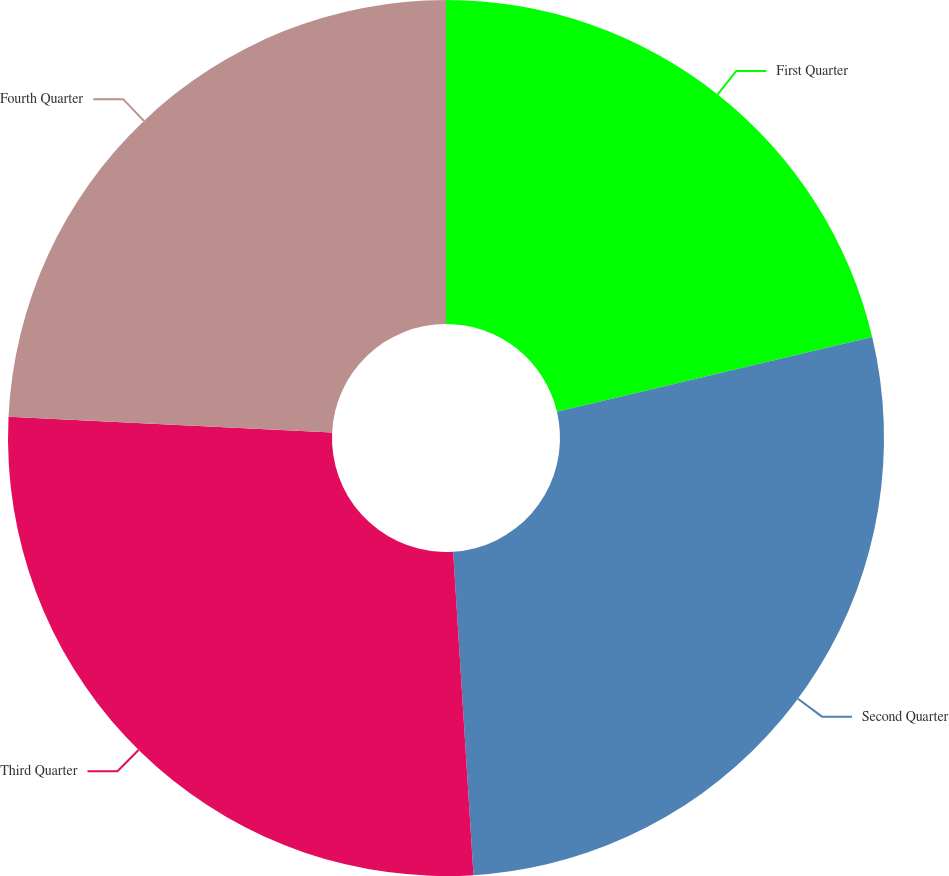Convert chart to OTSL. <chart><loc_0><loc_0><loc_500><loc_500><pie_chart><fcel>First Quarter<fcel>Second Quarter<fcel>Third Quarter<fcel>Fourth Quarter<nl><fcel>21.3%<fcel>27.7%<fcel>26.77%<fcel>24.23%<nl></chart> 